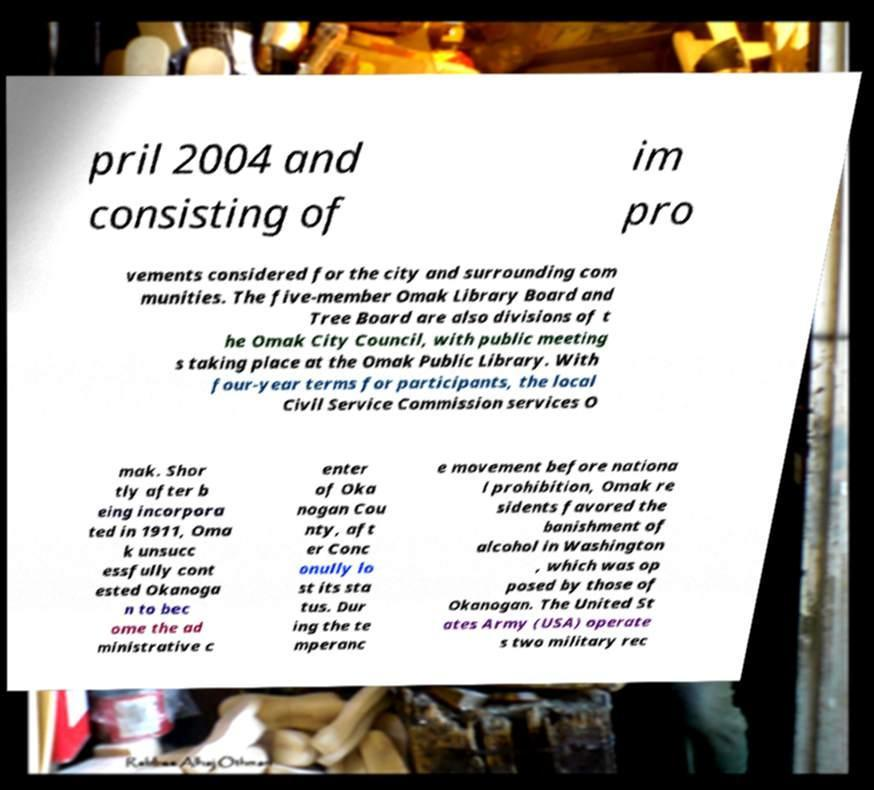Can you accurately transcribe the text from the provided image for me? pril 2004 and consisting of im pro vements considered for the city and surrounding com munities. The five-member Omak Library Board and Tree Board are also divisions of t he Omak City Council, with public meeting s taking place at the Omak Public Library. With four-year terms for participants, the local Civil Service Commission services O mak. Shor tly after b eing incorpora ted in 1911, Oma k unsucc essfully cont ested Okanoga n to bec ome the ad ministrative c enter of Oka nogan Cou nty, aft er Conc onully lo st its sta tus. Dur ing the te mperanc e movement before nationa l prohibition, Omak re sidents favored the banishment of alcohol in Washington , which was op posed by those of Okanogan. The United St ates Army (USA) operate s two military rec 